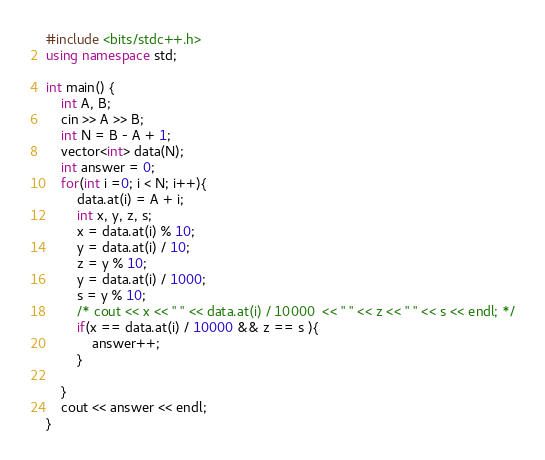Convert code to text. <code><loc_0><loc_0><loc_500><loc_500><_C++_>#include <bits/stdc++.h>
using namespace std;

int main() {
    int A, B;
    cin >> A >> B;
    int N = B - A + 1;
    vector<int> data(N);
    int answer = 0;
    for(int i =0; i < N; i++){
        data.at(i) = A + i;
        int x, y, z, s;
        x = data.at(i) % 10;
        y = data.at(i) / 10;
        z = y % 10;
        y = data.at(i) / 1000;
        s = y % 10;
        /* cout << x << " " << data.at(i) / 10000  << " " << z << " " << s << endl; */
        if(x == data.at(i) / 10000 && z == s ){
            answer++;
        } 

    }
    cout << answer << endl;
}</code> 